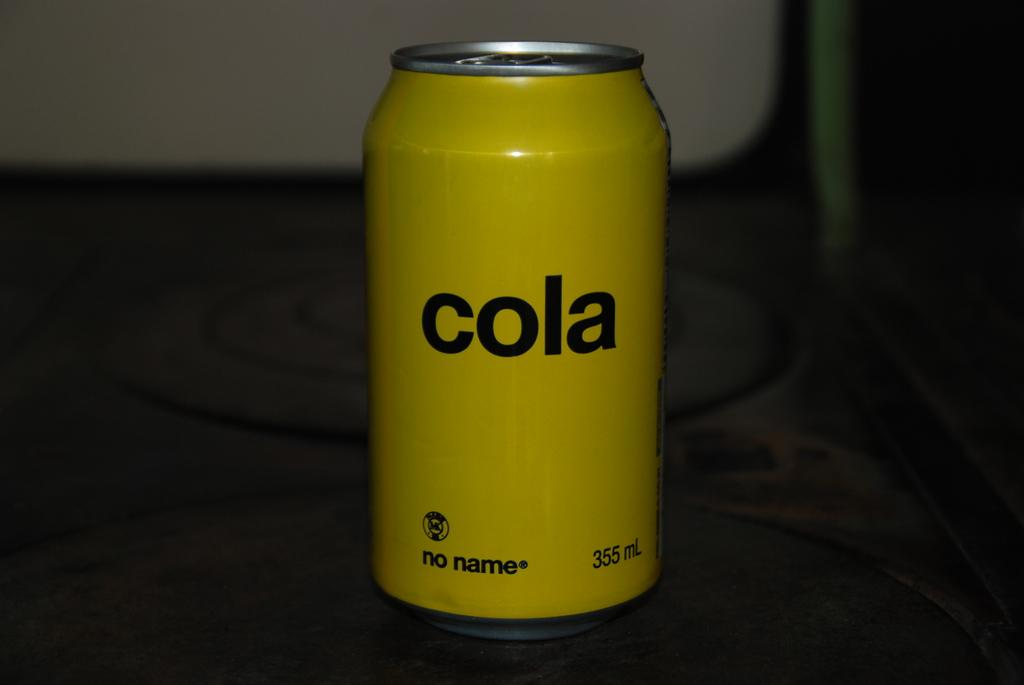<image>
Relay a brief, clear account of the picture shown. Yellow can which says COLA in black on it. 